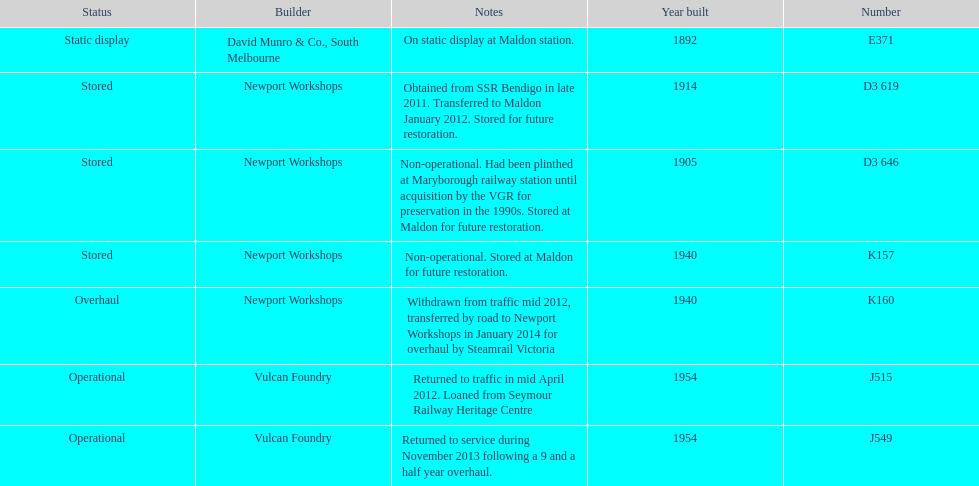Which are the only trains still in service? J515, J549. I'm looking to parse the entire table for insights. Could you assist me with that? {'header': ['Status', 'Builder', 'Notes', 'Year built', 'Number'], 'rows': [['Static display', 'David Munro & Co., South Melbourne', 'On static display at Maldon station.', '1892', 'E371'], ['Stored', 'Newport Workshops', 'Obtained from SSR Bendigo in late 2011. Transferred to Maldon January 2012. Stored for future restoration.', '1914', 'D3 619'], ['Stored', 'Newport Workshops', 'Non-operational. Had been plinthed at Maryborough railway station until acquisition by the VGR for preservation in the 1990s. Stored at Maldon for future restoration.', '1905', 'D3 646'], ['Stored', 'Newport Workshops', 'Non-operational. Stored at Maldon for future restoration.', '1940', 'K157'], ['Overhaul', 'Newport Workshops', 'Withdrawn from traffic mid 2012, transferred by road to Newport Workshops in January 2014 for overhaul by Steamrail Victoria', '1940', 'K160'], ['Operational', 'Vulcan Foundry', 'Returned to traffic in mid April 2012. Loaned from Seymour Railway Heritage Centre', '1954', 'J515'], ['Operational', 'Vulcan Foundry', 'Returned to service during November 2013 following a 9 and a half year overhaul.', '1954', 'J549']]} 